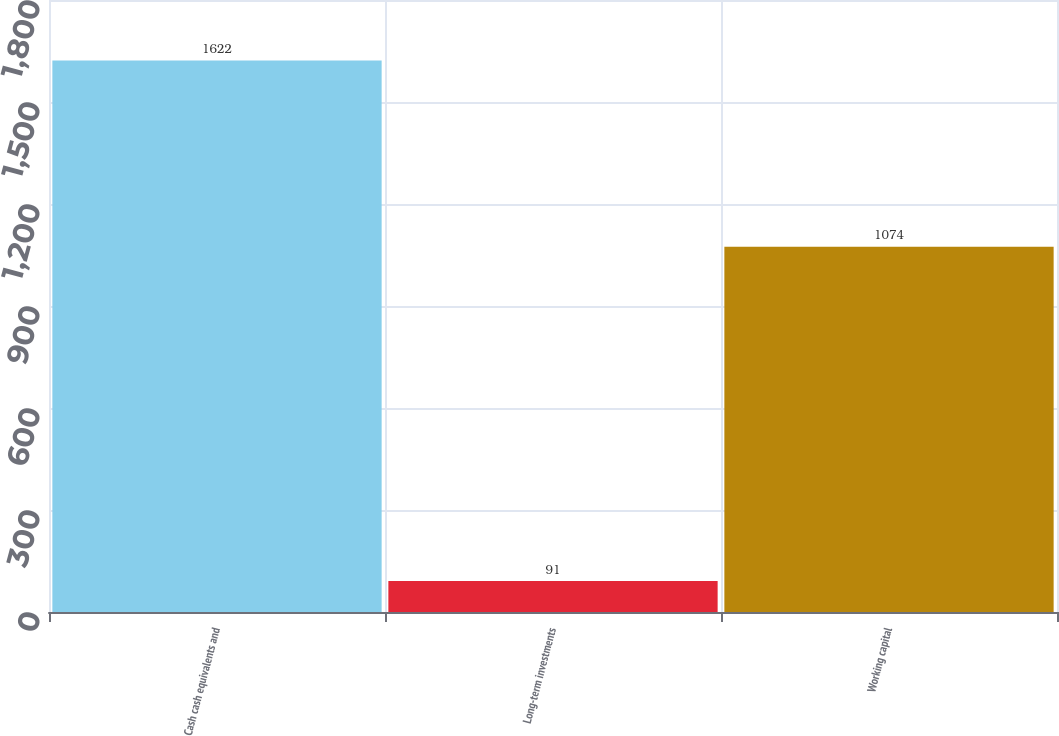Convert chart to OTSL. <chart><loc_0><loc_0><loc_500><loc_500><bar_chart><fcel>Cash cash equivalents and<fcel>Long-term investments<fcel>Working capital<nl><fcel>1622<fcel>91<fcel>1074<nl></chart> 